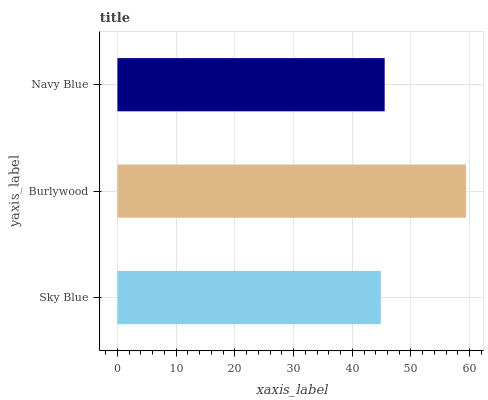Is Sky Blue the minimum?
Answer yes or no. Yes. Is Burlywood the maximum?
Answer yes or no. Yes. Is Navy Blue the minimum?
Answer yes or no. No. Is Navy Blue the maximum?
Answer yes or no. No. Is Burlywood greater than Navy Blue?
Answer yes or no. Yes. Is Navy Blue less than Burlywood?
Answer yes or no. Yes. Is Navy Blue greater than Burlywood?
Answer yes or no. No. Is Burlywood less than Navy Blue?
Answer yes or no. No. Is Navy Blue the high median?
Answer yes or no. Yes. Is Navy Blue the low median?
Answer yes or no. Yes. Is Sky Blue the high median?
Answer yes or no. No. Is Burlywood the low median?
Answer yes or no. No. 